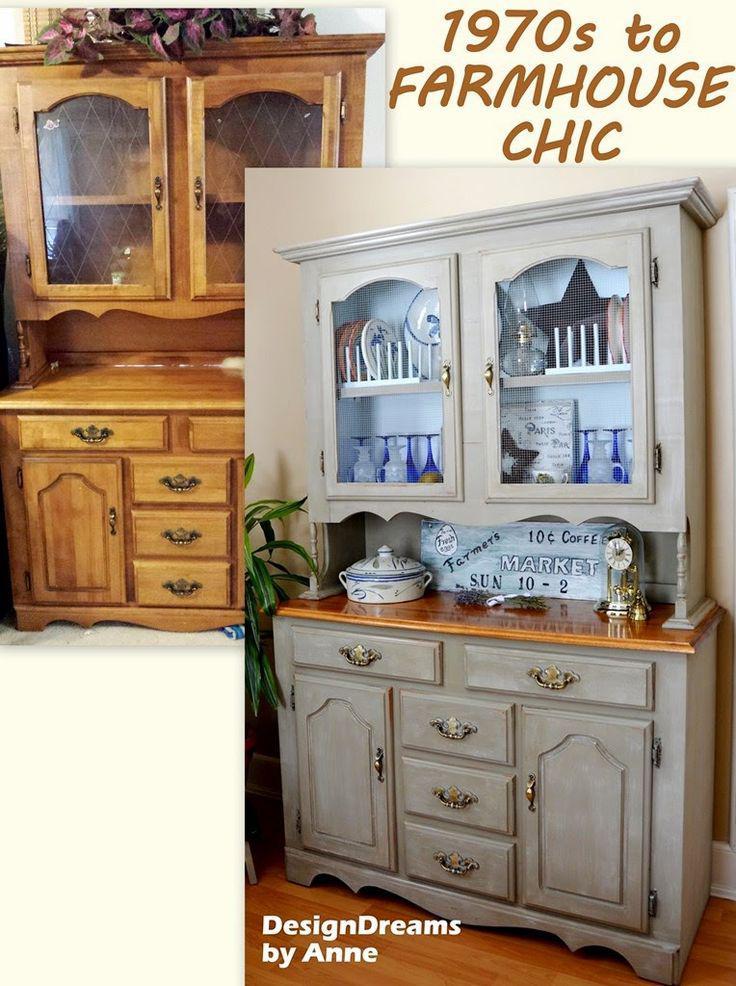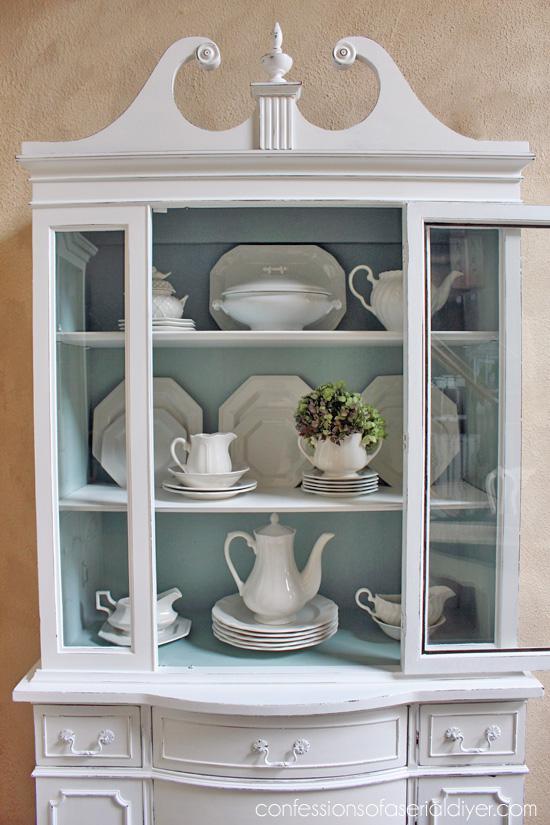The first image is the image on the left, the second image is the image on the right. For the images displayed, is the sentence "An image shows exactly one cabinet, which is sky blue." factually correct? Answer yes or no. No. 